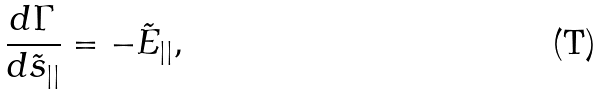<formula> <loc_0><loc_0><loc_500><loc_500>\frac { d \Gamma } { d \tilde { s } _ { | | } } = - \tilde { E } _ { | | } ,</formula> 